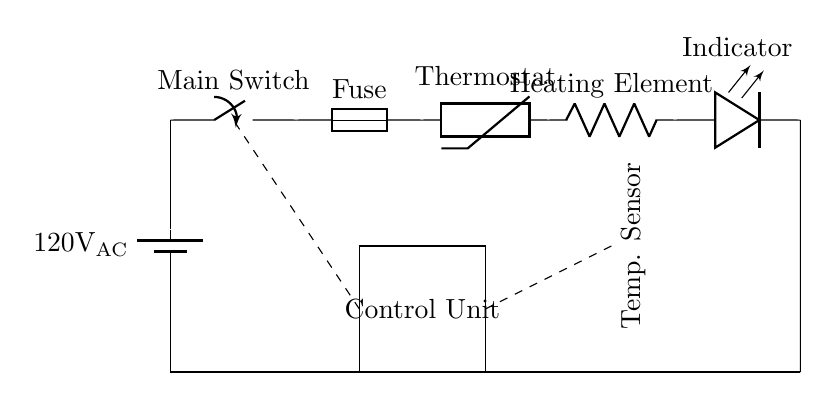What is the power source voltage? The diagram shows a battery component labeled with a voltage of 120 volts AC connected at the starting point of the circuit.
Answer: 120 volts AC What component acts as a safety measure in this circuit? The circuit includes a fuse component, which is specifically designed to prevent excessive current by breaking the circuit.
Answer: Fuse How does the temperature control mechanism work in this circuit? The circuit contains a thermostat labeled as a thermistor, which measures temperature and helps regulate the heating element's operation by controlling the flow of electricity based on the temperature readings.
Answer: Thermistor What indicates the operational status of the heating element? An LED component is incorporated in the circuit, which provides a visual indication when the heating element is operating.
Answer: Indicator What is the role of the control unit in this circuit? The control unit is represented by a rectangle in the circuit, and it processes signals from the temperature sensor to adjust the heating element's power, ensuring that the food warmer maintains the desired temperature.
Answer: Control Unit Where is the temperature sensor located in the circuit? The temperature sensor is a component labeled as a thermistor positioned above the heating element, which allows it to accurately measure the temperature of the food being warmed.
Answer: Near the heating element What is the primary function of the heating element in this circuit? The heating element is labeled as a resistor, which converts electrical energy into thermal energy to warm the food in the portable food warmer.
Answer: Heating Element 